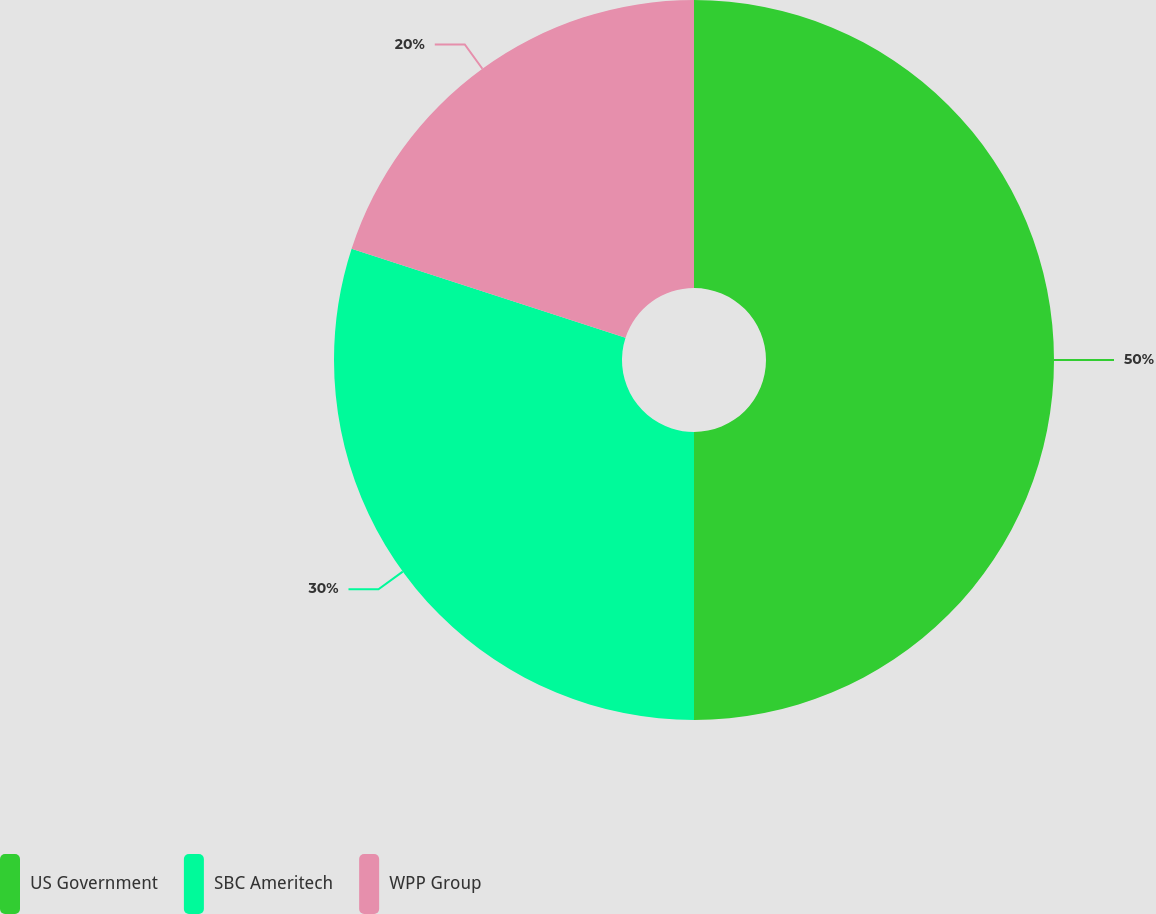<chart> <loc_0><loc_0><loc_500><loc_500><pie_chart><fcel>US Government<fcel>SBC Ameritech<fcel>WPP Group<nl><fcel>50.0%<fcel>30.0%<fcel>20.0%<nl></chart> 